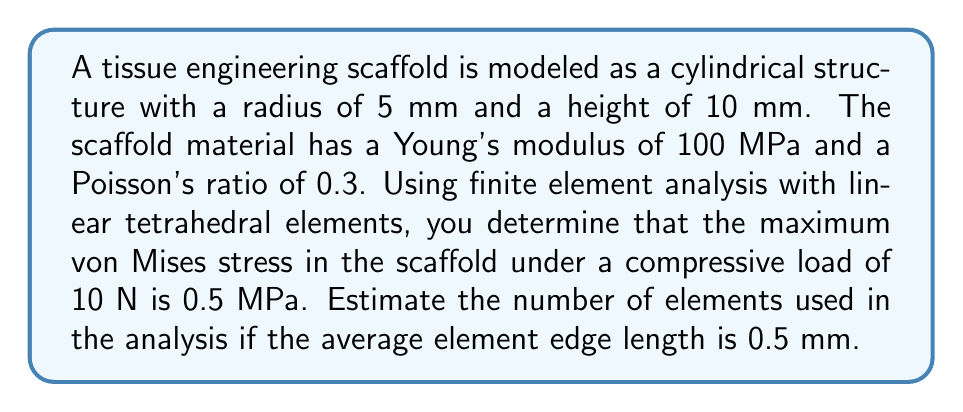Teach me how to tackle this problem. To estimate the number of elements, we'll follow these steps:

1) First, calculate the volume of the scaffold:
   $$V = \pi r^2 h = \pi \cdot (5\text{ mm})^2 \cdot 10\text{ mm} = 785.4\text{ mm}^3$$

2) The volume of a regular tetrahedron with edge length $a$ is:
   $$V_{tet} = \frac{\sqrt{2}}{12}a^3$$

3) With an average edge length of 0.5 mm:
   $$V_{tet} = \frac{\sqrt{2}}{12}(0.5\text{ mm})^3 = 0.0147\text{ mm}^3$$

4) The number of elements can be estimated by dividing the total volume by the volume of one tetrahedral element:
   $$N_{elements} \approx \frac{V}{V_{tet}} = \frac{785.4\text{ mm}^3}{0.0147\text{ mm}^3} = 53,428.6$$

5) Rounding to the nearest whole number:
   $$N_{elements} \approx 53,429$$

This estimation assumes perfect packing of tetrahedral elements, which is not realistic in practice. The actual number of elements may be slightly different due to mesh refinement near boundaries or regions of interest.
Answer: Approximately 53,429 elements 